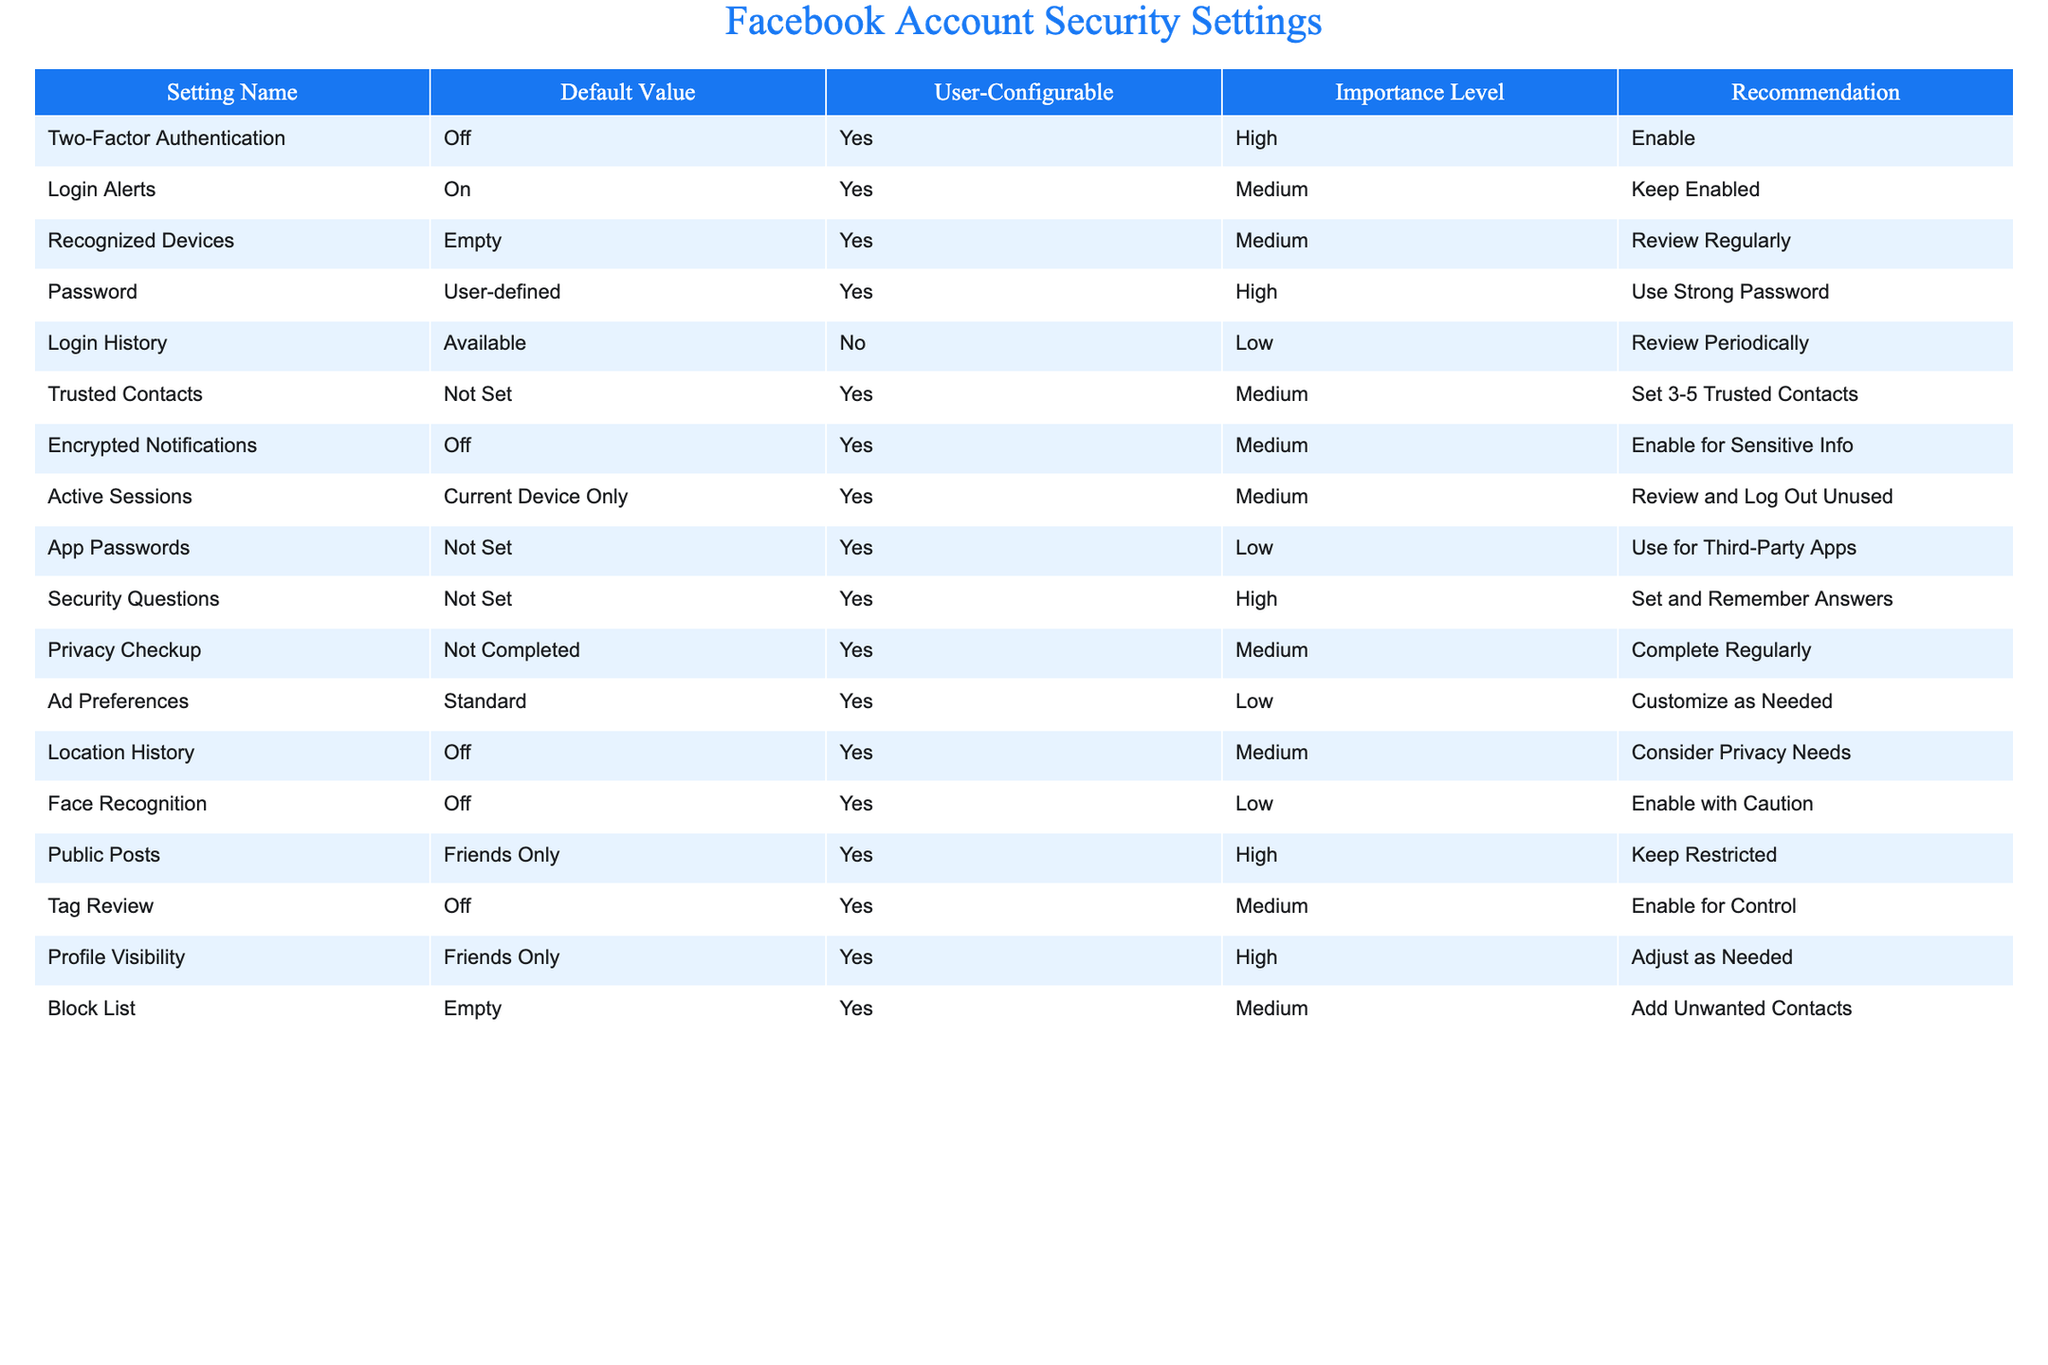What is the default value for Two-Factor Authentication? The table lists the default value of Two-Factor Authentication as "Off."
Answer: Off How many settings are user-configurable? Counting the "User-Configurable" column, there are 10 settings marked as "Yes."
Answer: 10 Is the Login Alerts setting turned on by default? The table shows that the default value for Login Alerts is "On."
Answer: Yes What is the importance level of Encrypted Notifications? According to the table, the importance level for Encrypted Notifications is "Medium."
Answer: Medium How many security settings have a high importance level? The settings with high importance levels are Two-Factor Authentication, Password, Security Questions, Public Posts, and Profile Visibility, totaling 5 settings.
Answer: 5 Are there any settings that are not set by default? The table indicates that Trusted Contacts, App Passwords, and Security Questions are marked as "Not Set."
Answer: Yes What is the recommendation for users regarding Password? The recommendation states users should "Use Strong Password."
Answer: Use Strong Password Which setting is recommended to be enabled for sensitive information? The recommendation for Encrypted Notifications is to enable it for sensitive information.
Answer: Encrypted Notifications What is the default status of Active Sessions? The default status of Active Sessions is "Current Device Only."
Answer: Current Device Only How should users handle their recognized devices? The recommendation is to "Review Regularly" regarding recognized devices.
Answer: Review Regularly Which settings have the lowest importance level? The settings with a low importance level are Login History, App Passwords, Ad Preferences, and Face Recognition, totaling 4 settings.
Answer: 4 Are any of the customizable settings set to "Empty" by default? Yes, the Recognized Devices and Block List settings are marked as "Empty."
Answer: Yes What is the recommendation for Login History? The recommendation for Login History is to "Review Periodically."
Answer: Review Periodically Which setting is recommended to be enabled for control over tags? The recommendation for Tag Review is to "Enable for Control."
Answer: Tag Review What is the default visibility setting for Public Posts? The table indicates that the default visibility for Public Posts is "Friends Only."
Answer: Friends Only Is Face Recognition enabled by default? The default value for Face Recognition is "Off."
Answer: Off 